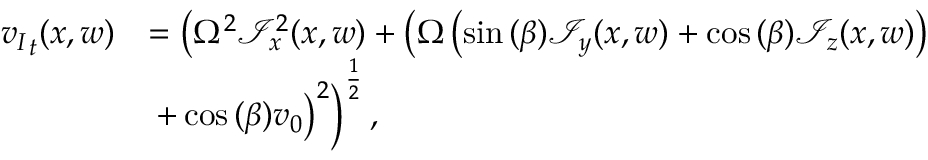<formula> <loc_0><loc_0><loc_500><loc_500>\begin{array} { r l } { { v _ { I } } _ { t } ( x , w ) } & { = \left ( \Omega ^ { 2 } \mathcal { I } _ { x } ^ { 2 } ( x , w ) + \left ( \Omega \left ( \sin { ( \beta ) } \mathcal { I } _ { y } ( x , w ) + \cos { ( \beta ) } \mathcal { I } _ { z } ( x , w ) \right ) } \\ & { + \cos { ( \beta ) } v _ { 0 } \right ) ^ { 2 } \right ) ^ { \frac { 1 } { 2 } } , } \end{array}</formula> 